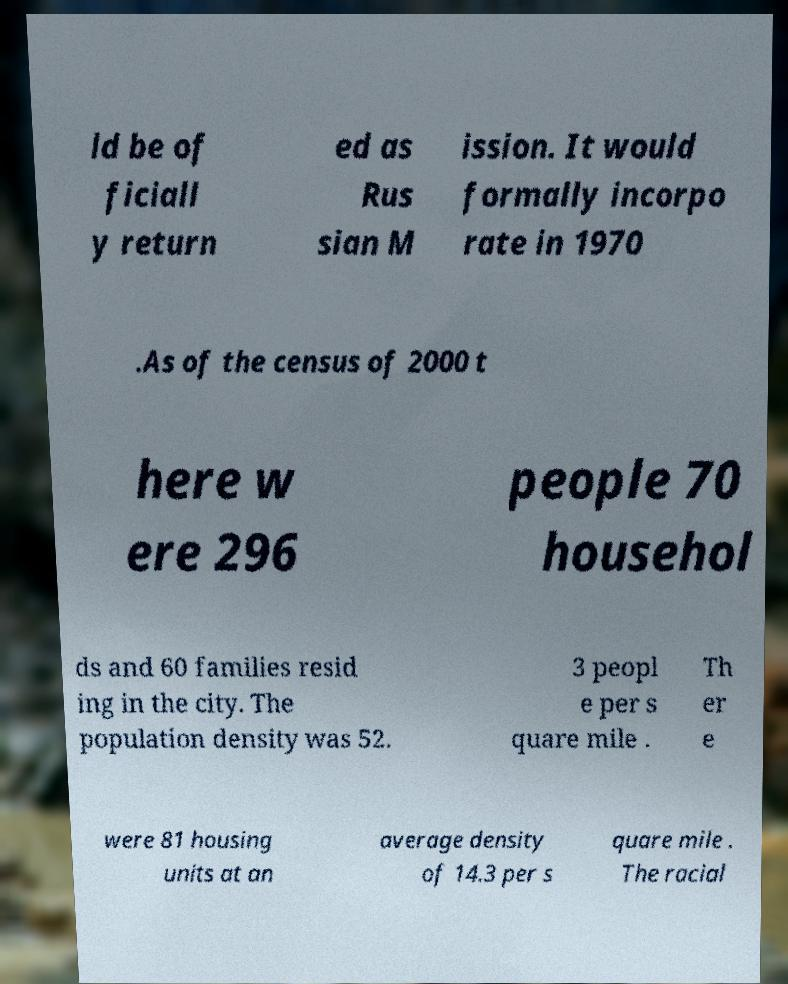Can you accurately transcribe the text from the provided image for me? ld be of ficiall y return ed as Rus sian M ission. It would formally incorpo rate in 1970 .As of the census of 2000 t here w ere 296 people 70 househol ds and 60 families resid ing in the city. The population density was 52. 3 peopl e per s quare mile . Th er e were 81 housing units at an average density of 14.3 per s quare mile . The racial 